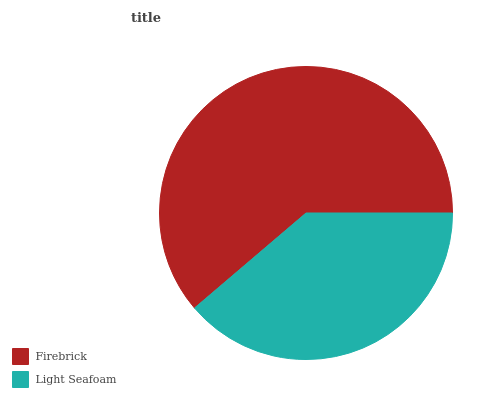Is Light Seafoam the minimum?
Answer yes or no. Yes. Is Firebrick the maximum?
Answer yes or no. Yes. Is Light Seafoam the maximum?
Answer yes or no. No. Is Firebrick greater than Light Seafoam?
Answer yes or no. Yes. Is Light Seafoam less than Firebrick?
Answer yes or no. Yes. Is Light Seafoam greater than Firebrick?
Answer yes or no. No. Is Firebrick less than Light Seafoam?
Answer yes or no. No. Is Firebrick the high median?
Answer yes or no. Yes. Is Light Seafoam the low median?
Answer yes or no. Yes. Is Light Seafoam the high median?
Answer yes or no. No. Is Firebrick the low median?
Answer yes or no. No. 